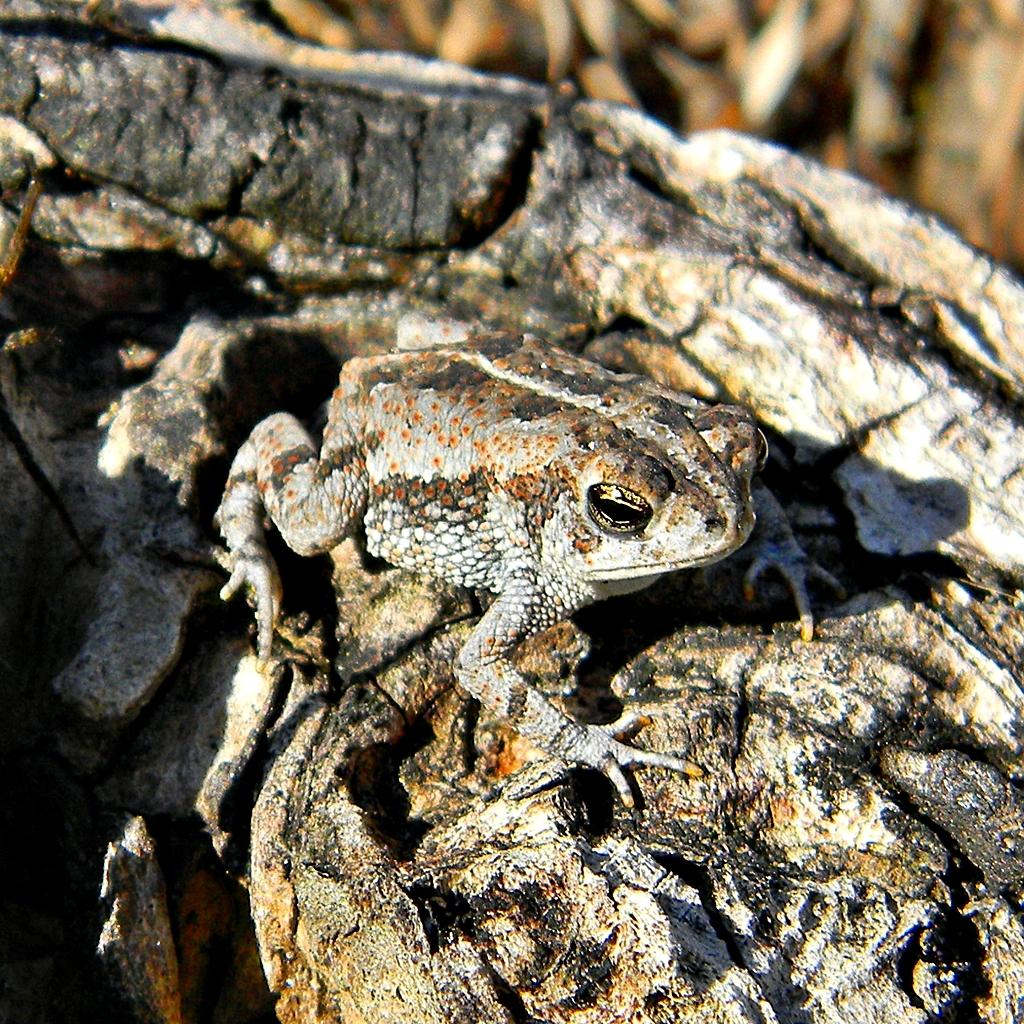What animal is present in the image? There is a frog in the image. Where is the frog located? The frog is on a rock. What type of tax is being discussed in the image? There is no mention of tax in the image; it features a frog on a rock. What brand of toothpaste is being advertised in the image? There is no toothpaste or advertisement present in the image. 